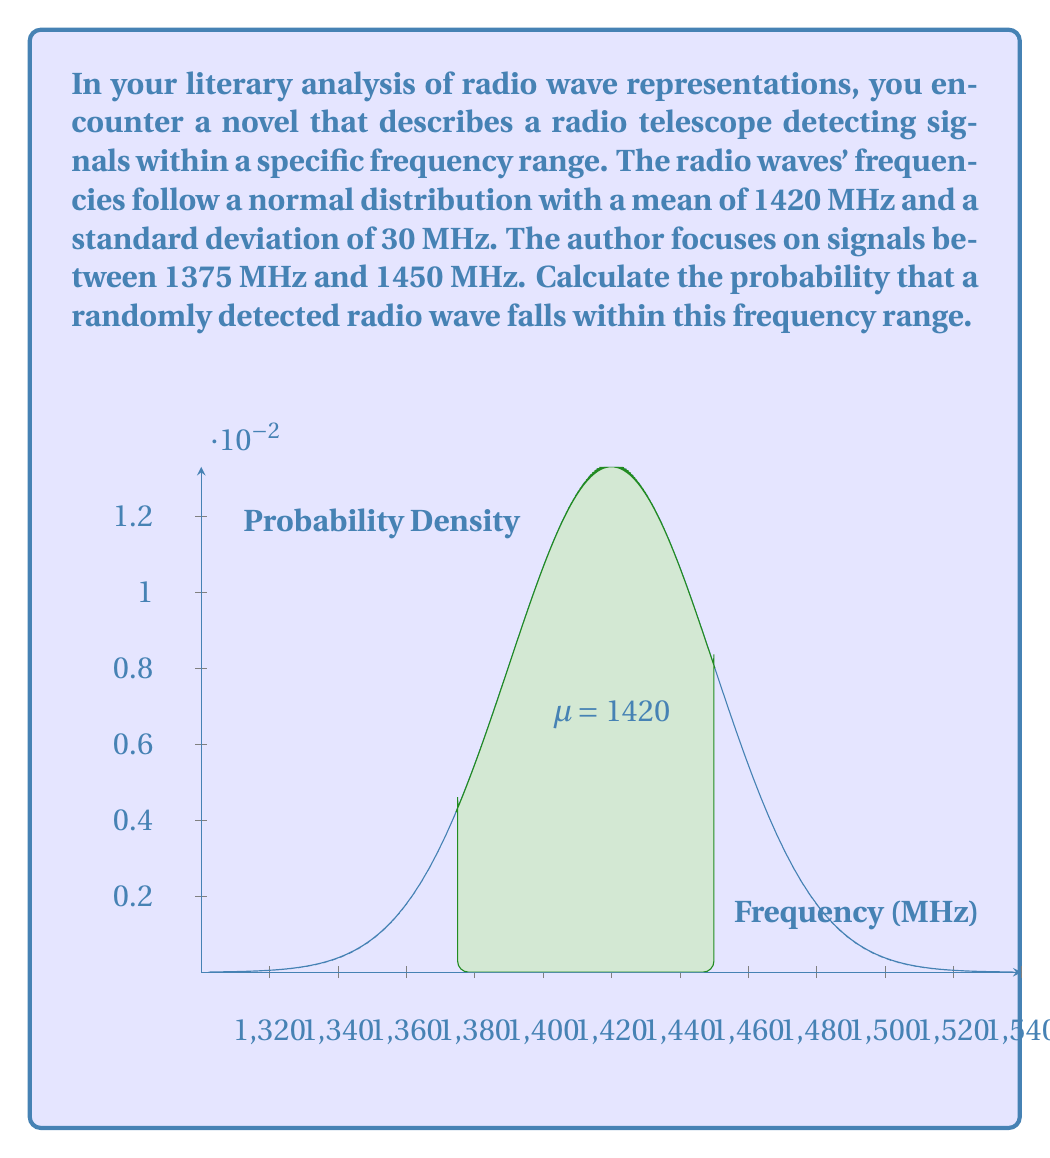Give your solution to this math problem. To solve this problem, we'll use the properties of the normal distribution and the concept of z-scores.

Step 1: Identify the given information
- Mean (μ) = 1420 MHz
- Standard deviation (σ) = 30 MHz
- Lower bound = 1375 MHz
- Upper bound = 1450 MHz

Step 2: Calculate the z-scores for the lower and upper bounds
z-score formula: $z = \frac{x - \mu}{\sigma}$

For the lower bound:
$z_1 = \frac{1375 - 1420}{30} = -1.5$

For the upper bound:
$z_2 = \frac{1450 - 1420}{30} = 1$

Step 3: Use the standard normal distribution table or a calculator to find the area under the curve between these z-scores

The probability is equal to the area between $z_1$ and $z_2$:
$P(-1.5 < Z < 1) = P(Z < 1) - P(Z < -1.5)$

Using a standard normal distribution table or calculator:
$P(Z < 1) \approx 0.8413$
$P(Z < -1.5) \approx 0.0668$

Step 4: Calculate the final probability
$P(-1.5 < Z < 1) = 0.8413 - 0.0668 \approx 0.7745$

Therefore, the probability that a randomly detected radio wave falls within the frequency range of 1375 MHz to 1450 MHz is approximately 0.7745 or 77.45%.
Answer: $0.7745$ or $77.45\%$ 